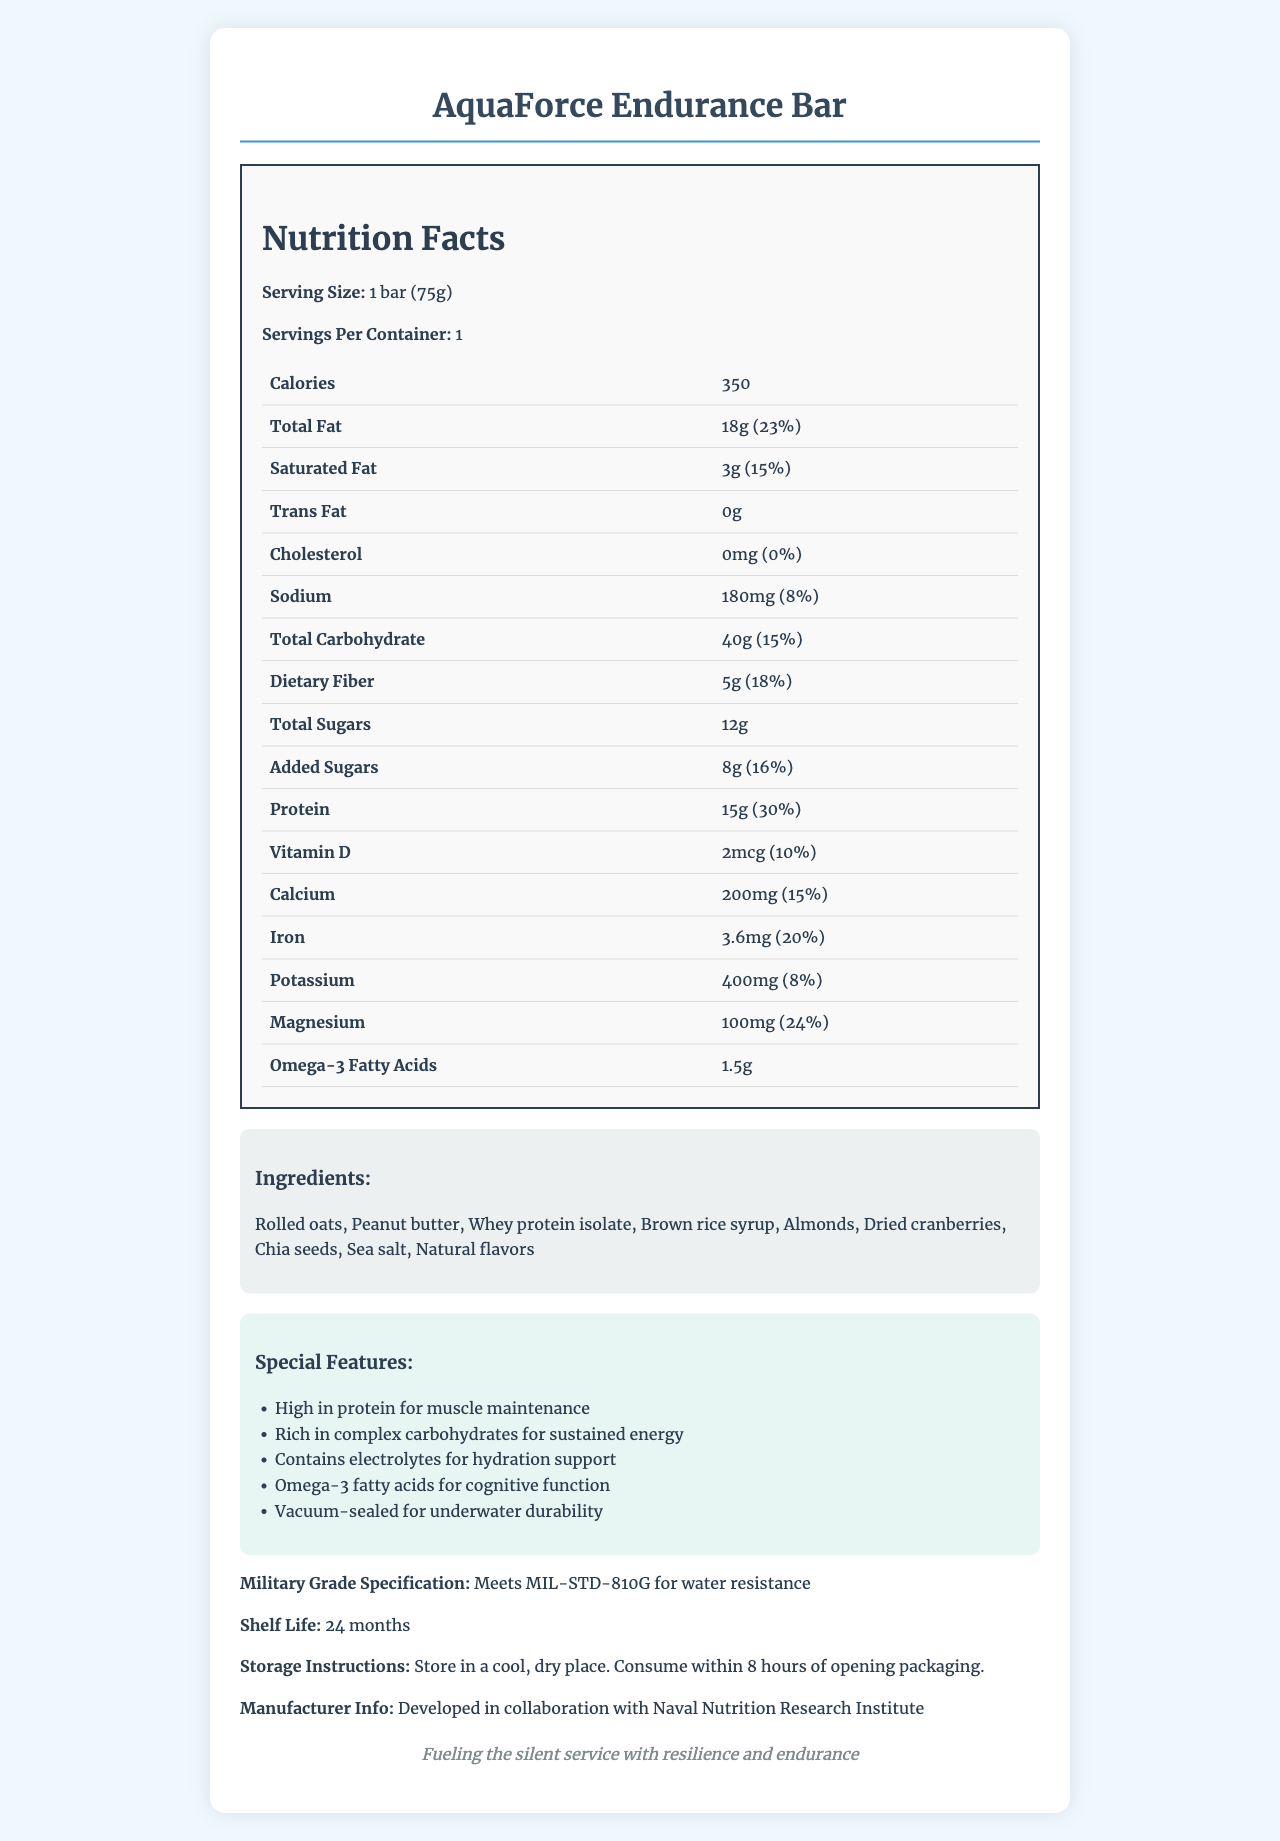What is the serving size of the AquaForce Endurance Bar? The serving size is clearly listed as "1 bar (75g)" in the document.
Answer: 1 bar (75g) How many calories are in one AquaForce Endurance Bar? The document states that there are 350 calories per bar.
Answer: 350 What percentage of daily recommended protein does one AquaForce Endurance Bar provide? The protein content is 15g and the daily value percentage is listed as 30%.
Answer: 30% How much dietary fiber is in one serving of the AquaForce Endurance Bar? The nutritional label lists the dietary fiber content as 5g.
Answer: 5g What are the primary ingredients of the AquaForce Endurance Bar? The ingredients are listed as: Rolled oats, Peanut butter, Whey protein isolate, Brown rice syrup, Almonds, Dried cranberries, Chia seeds, Sea salt, Natural flavors.
Answer: Rolled oats, Peanut butter, Whey protein isolate, Brown rice syrup, Almonds, Dried cranberries, Chia seeds, Sea salt, Natural flavors Does the AquaForce Endurance Bar contain any trans fats? The document lists the trans fat content as "0g".
Answer: No What is the shelf life of the AquaForce Endurance Bar? The shelf life is noted in the document as 24 months.
Answer: 24 months Which of the following is a special feature of the AquaForce Endurance Bar? A. Contains artificial preservatives B. Rich in complex carbohydrates C. Low sodium content The document lists "Rich in complex carbohydrates for sustained energy" as one of the special features.
Answer: B. Rich in complex carbohydrates How much calcium is present in one AquaForce Endurance Bar? A. 100mg B. 200mg C. 300mg D. 400mg The document lists the amount of calcium as 200mg.
Answer: B. 200mg Is the AquaForce Endurance Bar suitable for people with peanut allergies? One of the ingredients is peanut butter, making it unsuitable for people with peanut allergies.
Answer: No What is the main idea of the document? The document provides detailed nutrition facts, ingredients, special features, and military specifications of the AquaForce Endurance Bar, emphasizing its design for durability and health benefits for underwater missions.
Answer: The AquaForce Endurance Bar is a high-protein, nutrient-rich energy bar designed for long-duration underwater missions, featuring military-grade specifications and various health benefits. Who is the manufacturer of the AquaForce Endurance Bar? The document states that the bar was developed in collaboration with the Naval Nutrition Research Institute.
Answer: Naval Nutrition Research Institute What is the recommended storage condition for the AquaForce Endurance Bar? The document instructs to store the bar in a cool, dry place and consume within 8 hours of opening the packaging.
Answer: Store in a cool, dry place. Which vitamin does the AquaForce Endurance Bar provide and what is its daily value percentage? The document lists Vitamin D with an amount of 2mcg and a daily value percentage of 10%.
Answer: Vitamin D, 10% What is the amount of sodium in one AquaForce Endurance Bar? The sodium content is listed as 180mg with a daily value percentage of 8%.
Answer: 180mg Explain the benefits of the AquaForce Endurance Bar for underwater missions. The special features of the bar are tailored to provide nutritional support and durability for long-duration underwater missions, meeting military-grade specifications.
Answer: The bar is designed to provide high protein for muscle maintenance, complex carbohydrates for sustained energy, electrolytes for hydration support, omega-3 fatty acids for cognitive function, and is vacuum-sealed for underwater durability. What is the mission statement of the AquaForce Endurance Bar? The mission statement is explicitly mentioned at the end of the document.
Answer: Fueling the silent service with resilience and endurance 